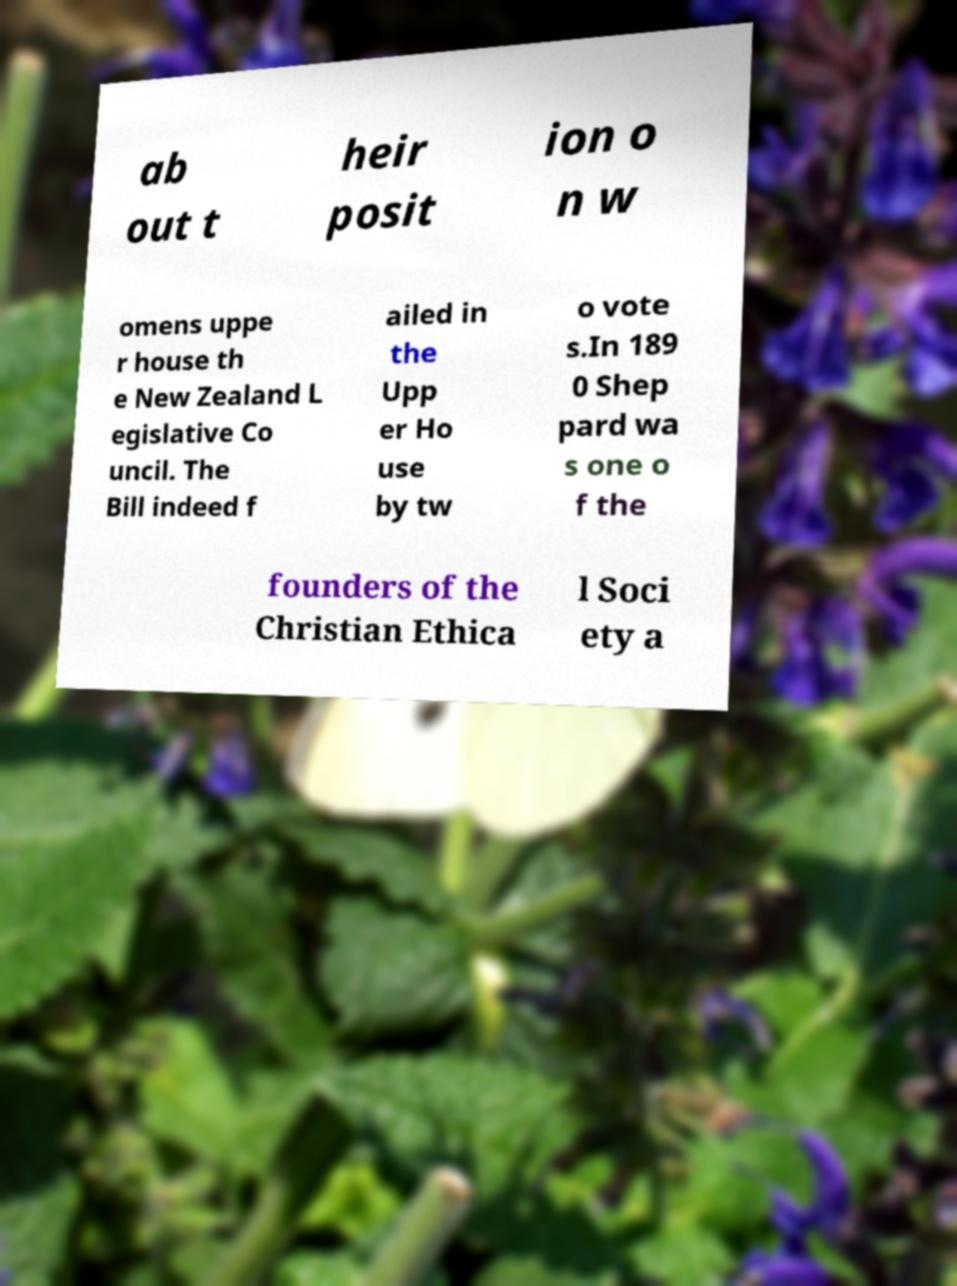Could you assist in decoding the text presented in this image and type it out clearly? ab out t heir posit ion o n w omens uppe r house th e New Zealand L egislative Co uncil. The Bill indeed f ailed in the Upp er Ho use by tw o vote s.In 189 0 Shep pard wa s one o f the founders of the Christian Ethica l Soci ety a 